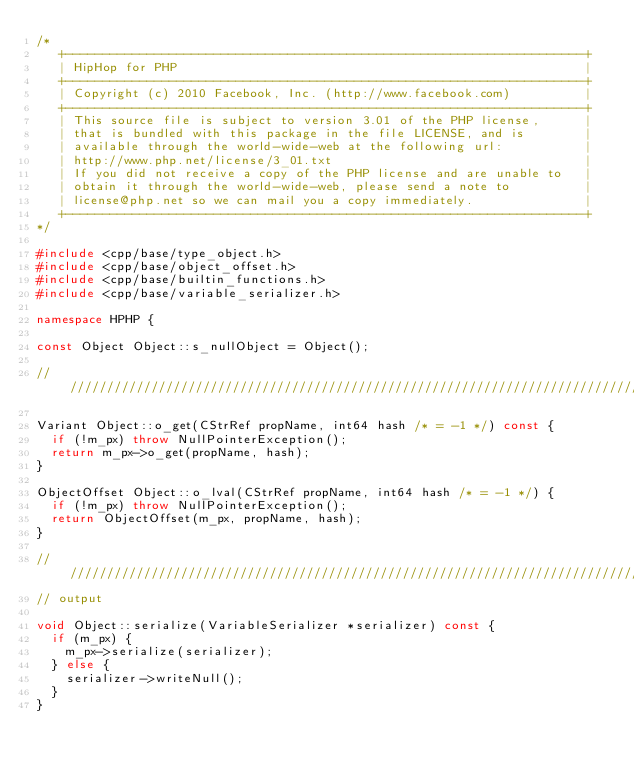Convert code to text. <code><loc_0><loc_0><loc_500><loc_500><_C++_>/*
   +----------------------------------------------------------------------+
   | HipHop for PHP                                                       |
   +----------------------------------------------------------------------+
   | Copyright (c) 2010 Facebook, Inc. (http://www.facebook.com)          |
   +----------------------------------------------------------------------+
   | This source file is subject to version 3.01 of the PHP license,      |
   | that is bundled with this package in the file LICENSE, and is        |
   | available through the world-wide-web at the following url:           |
   | http://www.php.net/license/3_01.txt                                  |
   | If you did not receive a copy of the PHP license and are unable to   |
   | obtain it through the world-wide-web, please send a note to          |
   | license@php.net so we can mail you a copy immediately.               |
   +----------------------------------------------------------------------+
*/

#include <cpp/base/type_object.h>
#include <cpp/base/object_offset.h>
#include <cpp/base/builtin_functions.h>
#include <cpp/base/variable_serializer.h>

namespace HPHP {

const Object Object::s_nullObject = Object();

///////////////////////////////////////////////////////////////////////////////

Variant Object::o_get(CStrRef propName, int64 hash /* = -1 */) const {
  if (!m_px) throw NullPointerException();
  return m_px->o_get(propName, hash);
}

ObjectOffset Object::o_lval(CStrRef propName, int64 hash /* = -1 */) {
  if (!m_px) throw NullPointerException();
  return ObjectOffset(m_px, propName, hash);
}

///////////////////////////////////////////////////////////////////////////////
// output

void Object::serialize(VariableSerializer *serializer) const {
  if (m_px) {
    m_px->serialize(serializer);
  } else {
    serializer->writeNull();
  }
}
</code> 